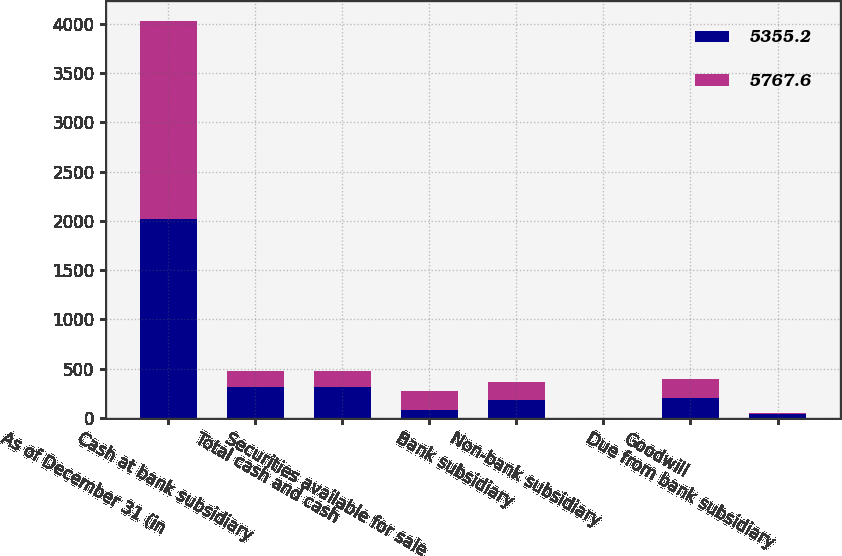<chart> <loc_0><loc_0><loc_500><loc_500><stacked_bar_chart><ecel><fcel>As of December 31 (in<fcel>Cash at bank subsidiary<fcel>Total cash and cash<fcel>Securities available for sale<fcel>Bank subsidiary<fcel>Non-bank subsidiary<fcel>Goodwill<fcel>Due from bank subsidiary<nl><fcel>5355.2<fcel>2016<fcel>308.7<fcel>308.7<fcel>75.3<fcel>183.65<fcel>0.9<fcel>197.1<fcel>36.5<nl><fcel>5767.6<fcel>2015<fcel>170.2<fcel>170.2<fcel>201.4<fcel>183.65<fcel>0.8<fcel>197.1<fcel>8.1<nl></chart> 